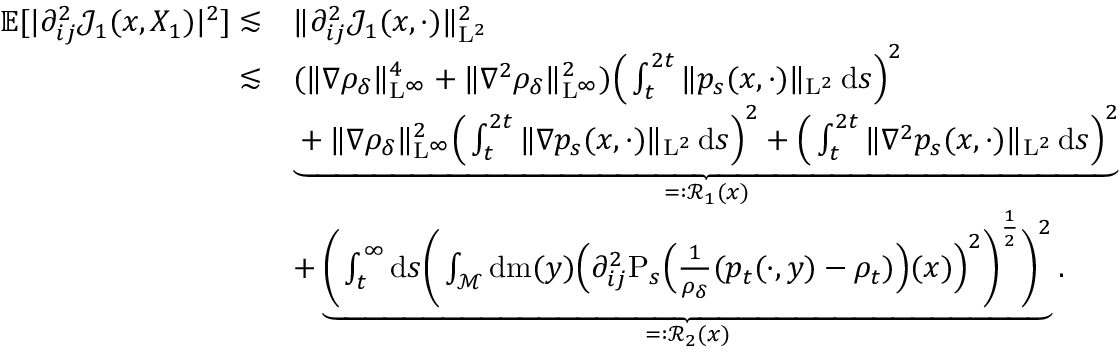Convert formula to latex. <formula><loc_0><loc_0><loc_500><loc_500>\begin{array} { r l } { \mathbb { E } [ | \partial _ { i j } ^ { 2 } \mathcal { J } _ { 1 } ( x , X _ { 1 } ) | ^ { 2 } ] \lesssim } & { \| \partial _ { i j } ^ { 2 } \mathcal { J } _ { 1 } ( x , \cdot ) \| _ { L ^ { 2 } } ^ { 2 } } \\ { \lesssim } & { ( \| \nabla \rho _ { \delta } \| _ { L ^ { \infty } } ^ { 4 } + \| \nabla ^ { 2 } \rho _ { \delta } \| _ { L ^ { \infty } } ^ { 2 } ) \left ( \int _ { t } ^ { 2 t } \| p _ { s } ( x , \cdot ) \| _ { L ^ { 2 } } \, d s \right ) ^ { 2 } } \\ & { \underbrace { + \| \nabla \rho _ { \delta } \| _ { L ^ { \infty } } ^ { 2 } \left ( \int _ { t } ^ { 2 t } \| \nabla p _ { s } ( x , \cdot ) \| _ { L ^ { 2 } } \, d s \right ) ^ { 2 } + \left ( \int _ { t } ^ { 2 t } \| \nabla ^ { 2 } p _ { s } ( x , \cdot ) \| _ { L ^ { 2 } } \, d s \right ) ^ { 2 } } _ { = \colon \mathcal { R } _ { 1 } ( x ) } } \\ & { + \underbrace { \left ( \int _ { t } ^ { \infty } d s \left ( \int _ { \mathcal { M } } d m ( y ) \left ( \partial _ { i j } ^ { 2 } P _ { s } \left ( \frac { 1 } { \rho _ { \delta } } ( p _ { t } ( \cdot , y ) - \rho _ { t } ) \right ) ( x ) \right ) ^ { 2 } \right ) ^ { \frac { 1 } { 2 } } \right ) ^ { 2 } } _ { = \colon \mathcal { R } _ { 2 } ( x ) } . } \end{array}</formula> 